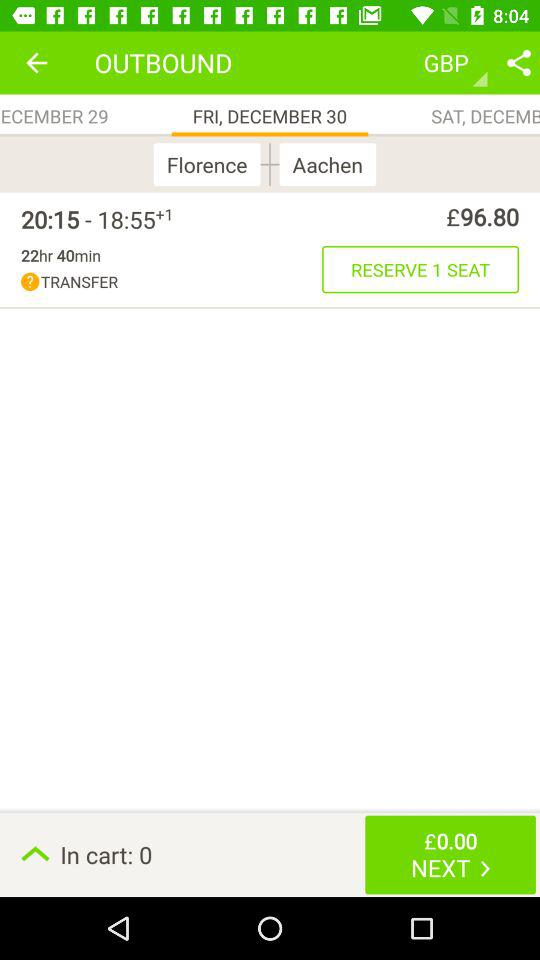What is the selected date for the reservation? The selected date for the reservation is Friday, December 30. 